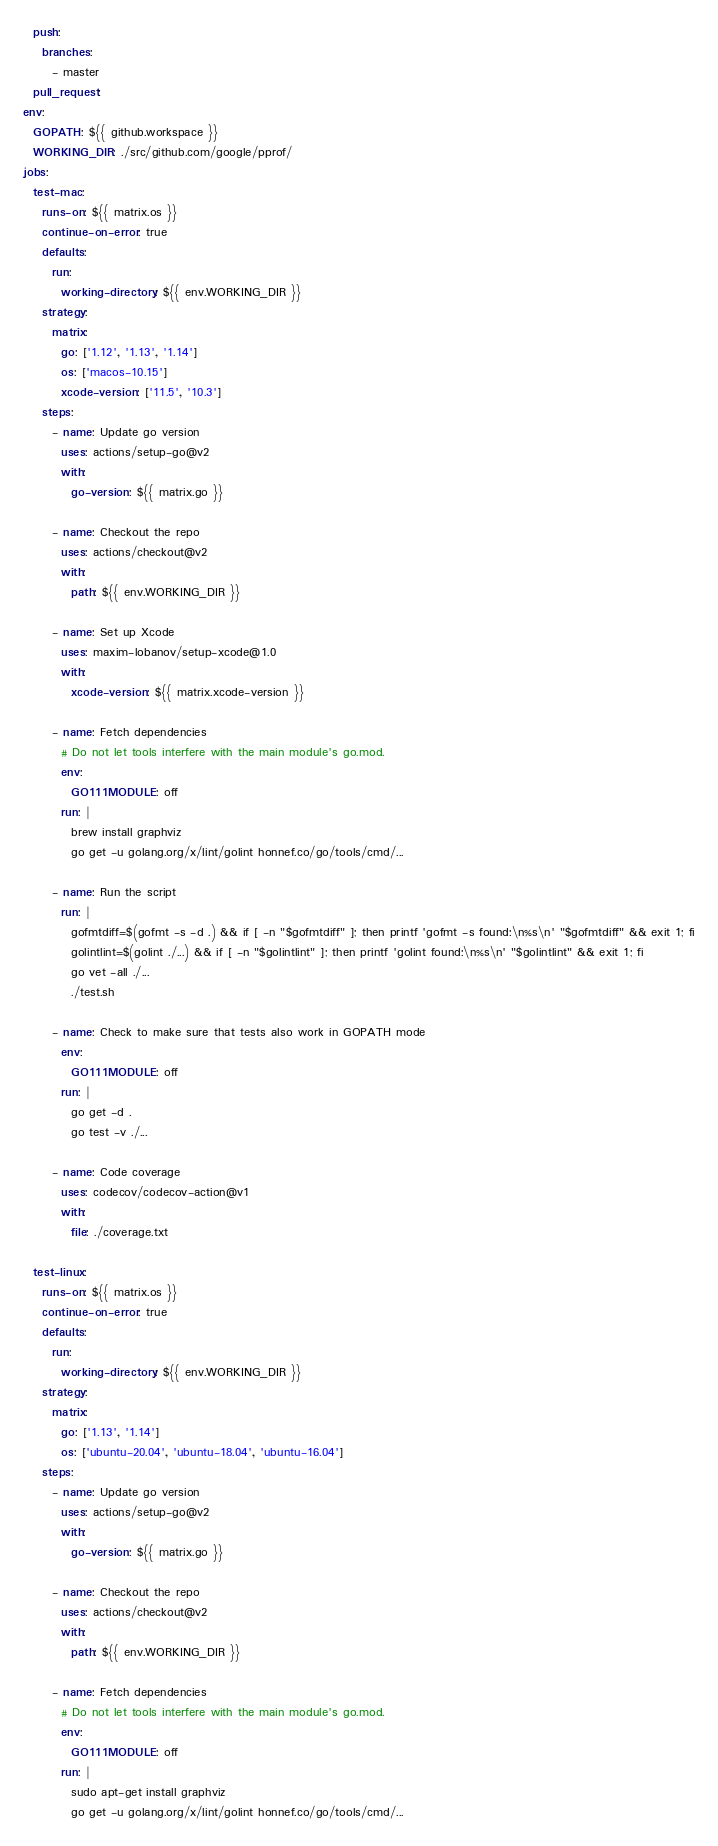<code> <loc_0><loc_0><loc_500><loc_500><_YAML_>  push:
    branches:
      - master
  pull_request:
env:
  GOPATH: ${{ github.workspace }}
  WORKING_DIR: ./src/github.com/google/pprof/
jobs:
  test-mac:
    runs-on: ${{ matrix.os }} 
    continue-on-error: true
    defaults:
      run:
        working-directory: ${{ env.WORKING_DIR }}
    strategy:
      matrix:
        go: ['1.12', '1.13', '1.14']
        os: ['macos-10.15']
        xcode-version: ['11.5', '10.3']
    steps:
      - name: Update go version
        uses: actions/setup-go@v2
        with:
          go-version: ${{ matrix.go }}

      - name: Checkout the repo
        uses: actions/checkout@v2
        with:
          path: ${{ env.WORKING_DIR }}

      - name: Set up Xcode
        uses: maxim-lobanov/setup-xcode@1.0
        with:
          xcode-version: ${{ matrix.xcode-version }}

      - name: Fetch dependencies
        # Do not let tools interfere with the main module's go.mod.
        env: 
          GO111MODULE: off         
        run: |
          brew install graphviz
          go get -u golang.org/x/lint/golint honnef.co/go/tools/cmd/...

      - name: Run the script 
        run: |
          gofmtdiff=$(gofmt -s -d .) && if [ -n "$gofmtdiff" ]; then printf 'gofmt -s found:\n%s\n' "$gofmtdiff" && exit 1; fi
          golintlint=$(golint ./...) && if [ -n "$golintlint" ]; then printf 'golint found:\n%s\n' "$golintlint" && exit 1; fi
          go vet -all ./...
          ./test.sh

      - name: Check to make sure that tests also work in GOPATH mode
        env: 
          GO111MODULE: off
        run: |
          go get -d .
          go test -v ./...

      - name: Code coverage
        uses: codecov/codecov-action@v1
        with:
          file: ./coverage.txt

  test-linux:
    runs-on: ${{ matrix.os }}
    continue-on-error: true
    defaults:
      run:
        working-directory: ${{ env.WORKING_DIR }} 
    strategy:
      matrix:
        go: ['1.13', '1.14']
        os: ['ubuntu-20.04', 'ubuntu-18.04', 'ubuntu-16.04'] 
    steps:
      - name: Update go version
        uses: actions/setup-go@v2
        with:
          go-version: ${{ matrix.go }}

      - name: Checkout the repo
        uses: actions/checkout@v2
        with:
          path: ${{ env.WORKING_DIR }}

      - name: Fetch dependencies
        # Do not let tools interfere with the main module's go.mod.
        env: 
          GO111MODULE: off         
        run: |
          sudo apt-get install graphviz
          go get -u golang.org/x/lint/golint honnef.co/go/tools/cmd/...
</code> 